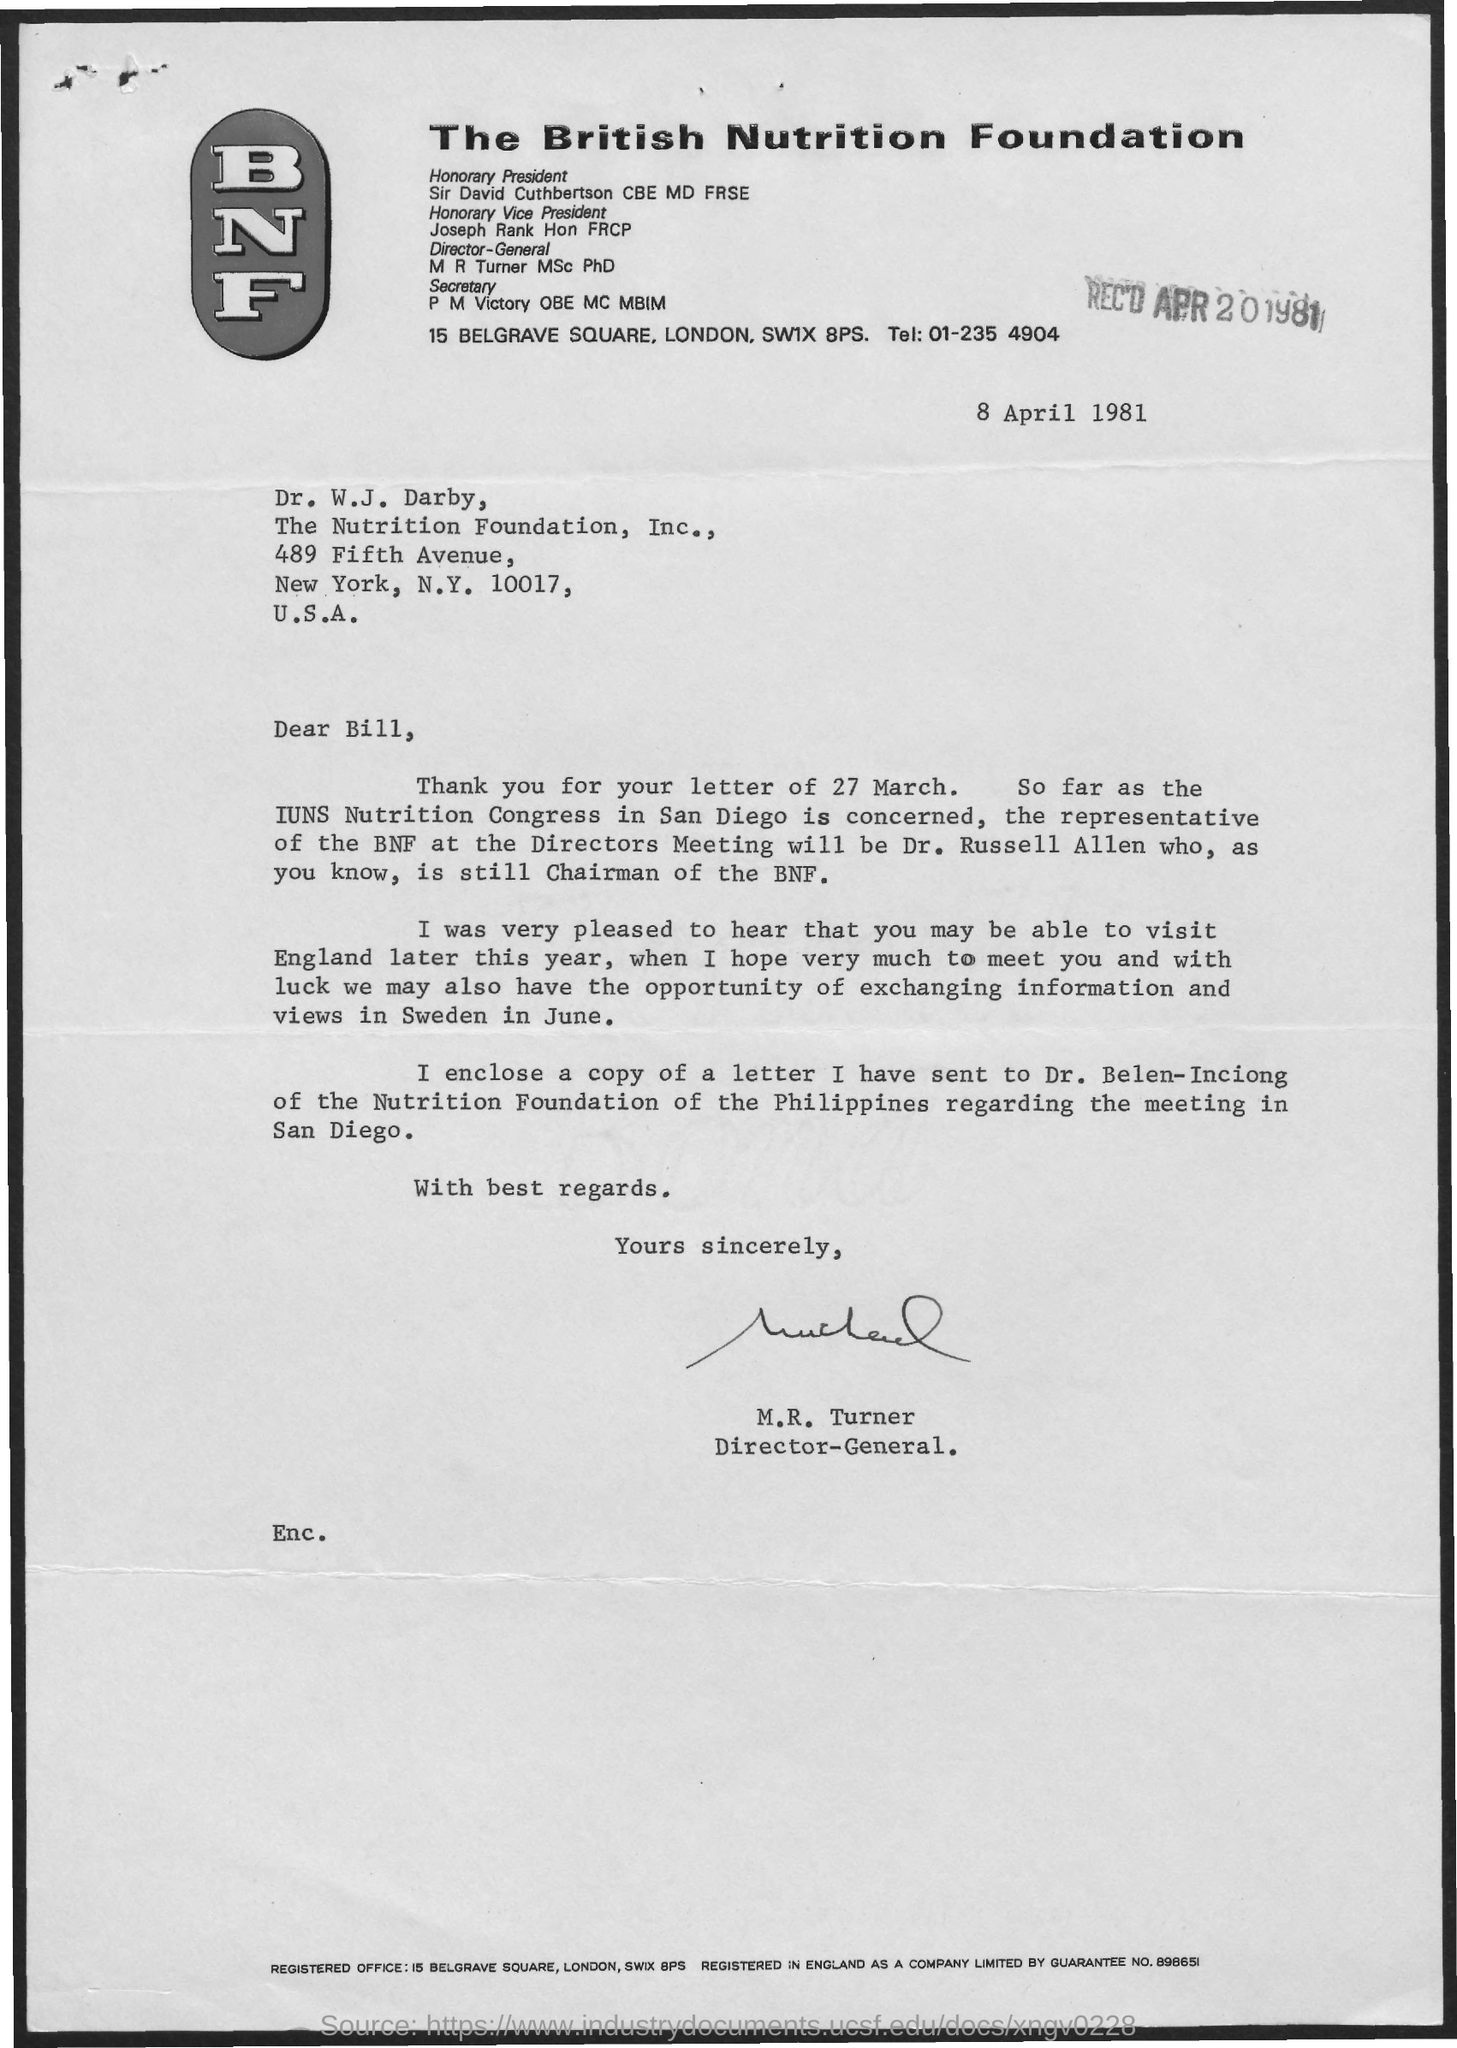Outline some significant characteristics in this image. The letter was received on April 20, 1981. The letter is from a person named M.R. Turner. The letter is addressed to Dr. W.J. Darby. The date on the document is 8 April 1981. 